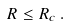Convert formula to latex. <formula><loc_0><loc_0><loc_500><loc_500>R \leq R _ { c } \, .</formula> 